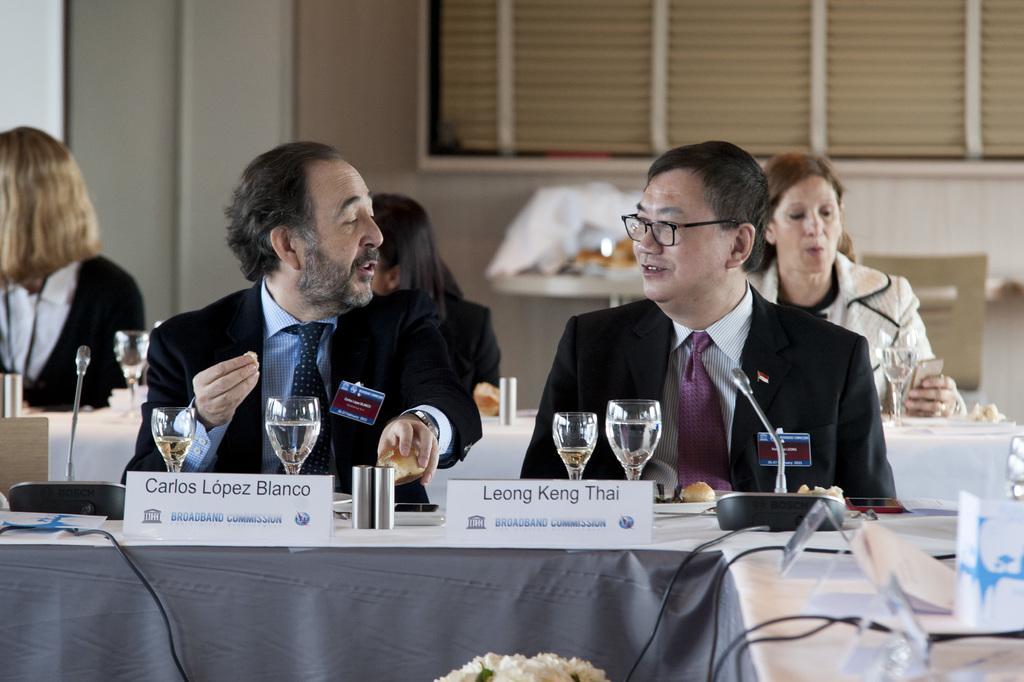Can you describe this image briefly? In this image i can see group of people sitting i can see two glasses, board on a table at the back ground i can see a window. 